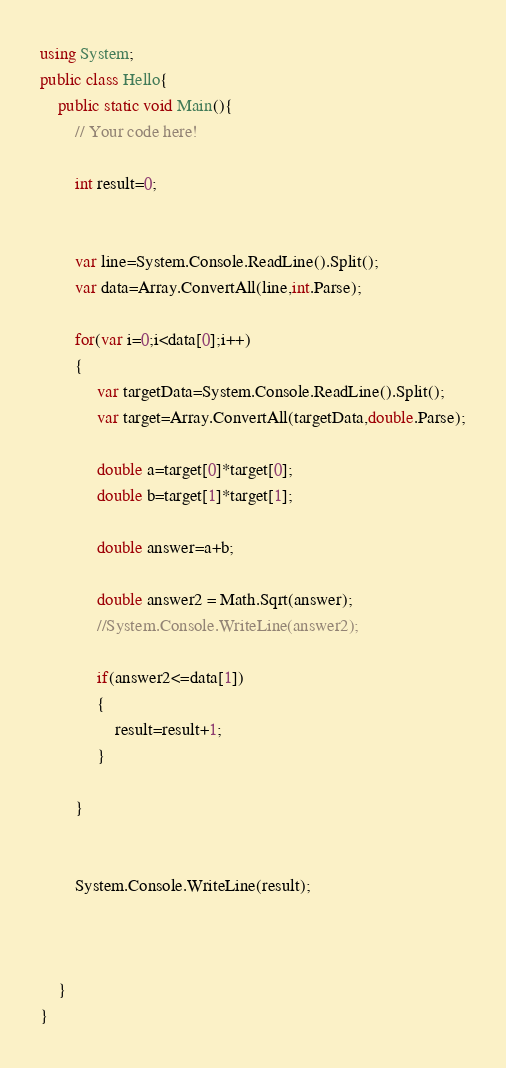Convert code to text. <code><loc_0><loc_0><loc_500><loc_500><_C#_>using System;
public class Hello{
    public static void Main(){
        // Your code here!
        
        int result=0;
        
        
        var line=System.Console.ReadLine().Split();
        var data=Array.ConvertAll(line,int.Parse);
        
        for(var i=0;i<data[0];i++)
        {
             var targetData=System.Console.ReadLine().Split();
             var target=Array.ConvertAll(targetData,double.Parse);
             
             double a=target[0]*target[0];
             double b=target[1]*target[1];
             
             double answer=a+b;
             
             double answer2 = Math.Sqrt(answer);
             //System.Console.WriteLine(answer2);
             
             if(answer2<=data[1])
             {
                 result=result+1;
             }
             
        }
        
        
        System.Console.WriteLine(result);

        
    
    }
}
</code> 